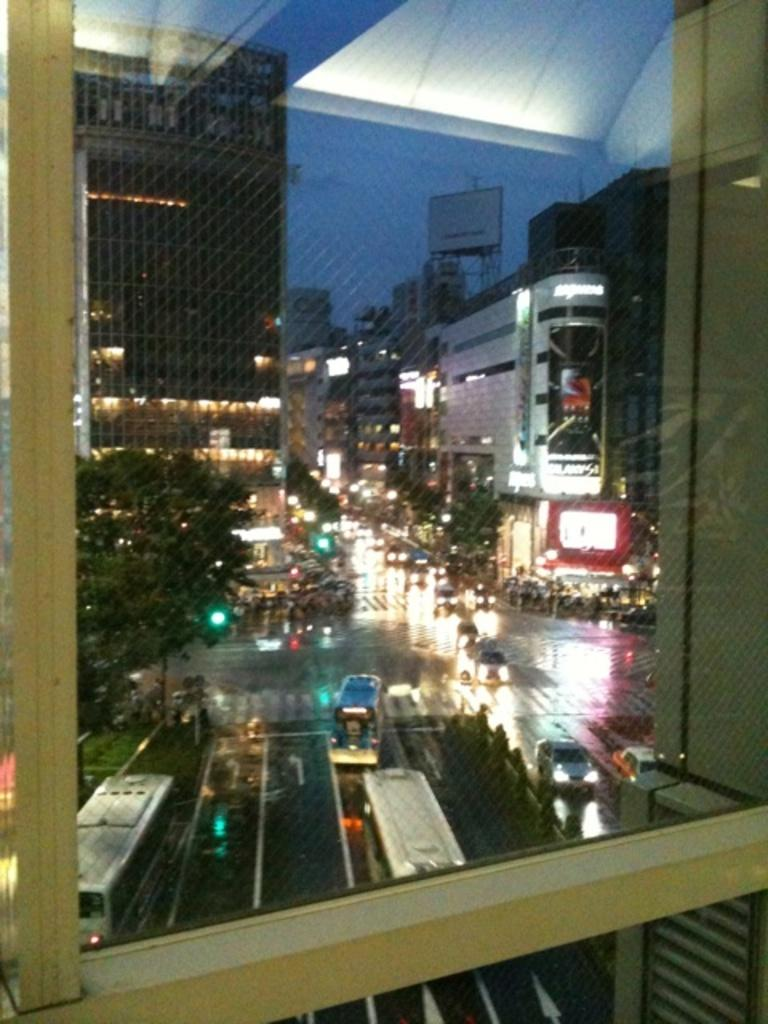What can be seen on the road in the image? There are vehicles on the road in the image. What type of natural elements are present in the image? There are trees in the image. What type of man-made structures can be seen in the image? There are buildings in the image. What type of illumination is present in the image? There are lights in the image. What can be seen in the background of the image? The sky is visible in the background of the image. Where is the lunchroom located in the image? There is no lunchroom present in the image. What type of animals can be seen in the zoo in the image? There is no zoo present in the image. 